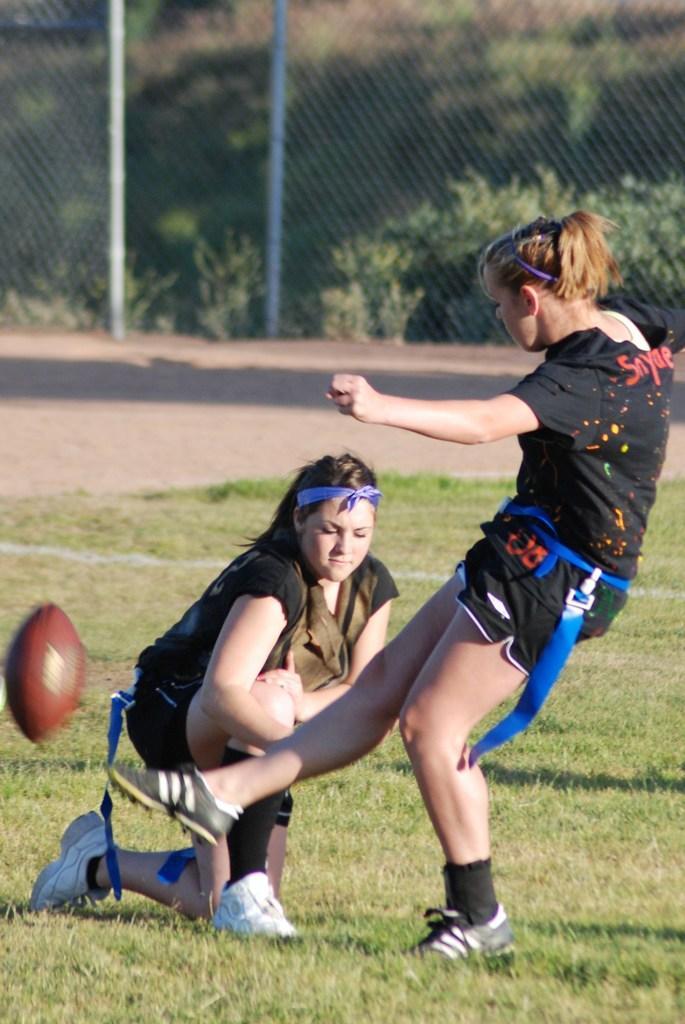How would you summarize this image in a sentence or two? In the center of the image we can see a lady is sitting on her knee. On the right side of the image we can see a lady is playing. In the background of the image we can see the mesh and some plants. On the left side of the image we can see a ball. At the bottom of the image we can see the ground. 